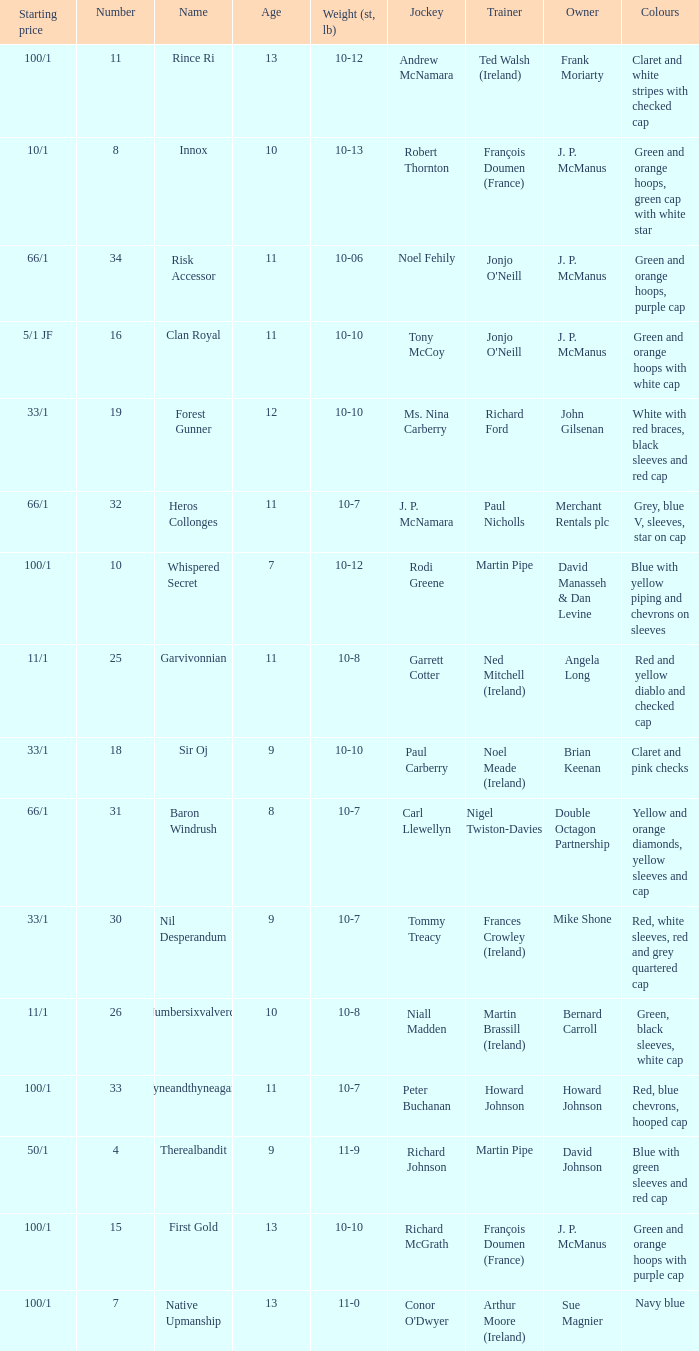What was the name of the entrant with an owner named David Johnson? Therealbandit. 